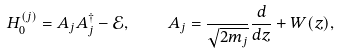<formula> <loc_0><loc_0><loc_500><loc_500>H _ { 0 } ^ { ( j ) } = A _ { j } A ^ { \dagger } _ { j } - \mathcal { E } , \quad A _ { j } = \frac { } { \sqrt { 2 m _ { j } } } \frac { d } { d z } + W ( z ) ,</formula> 